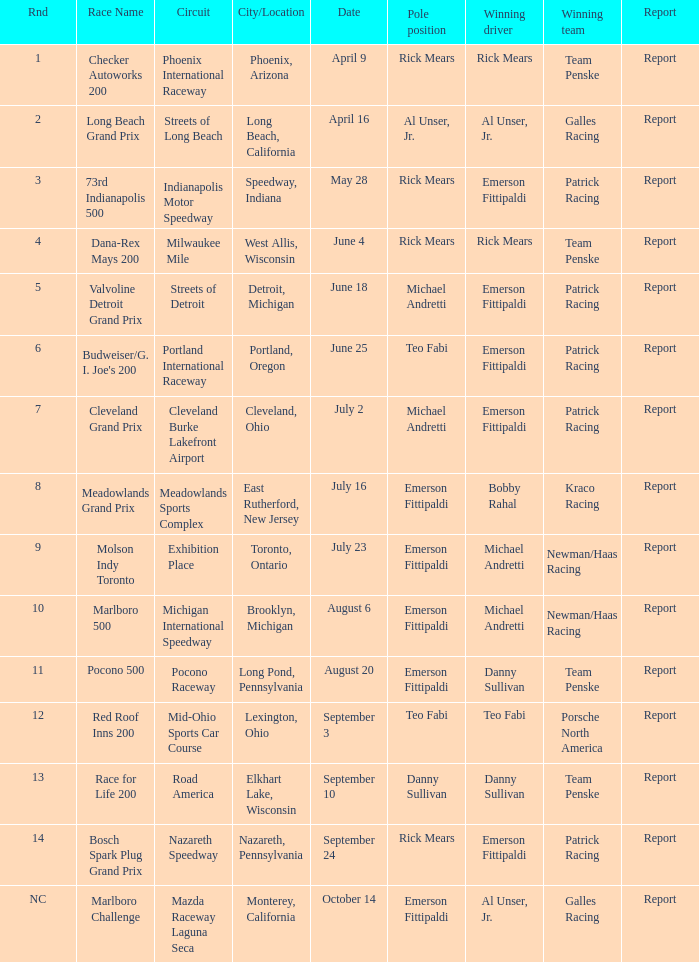Who occupied the pole position for the round corresponding to 12? Teo Fabi. 